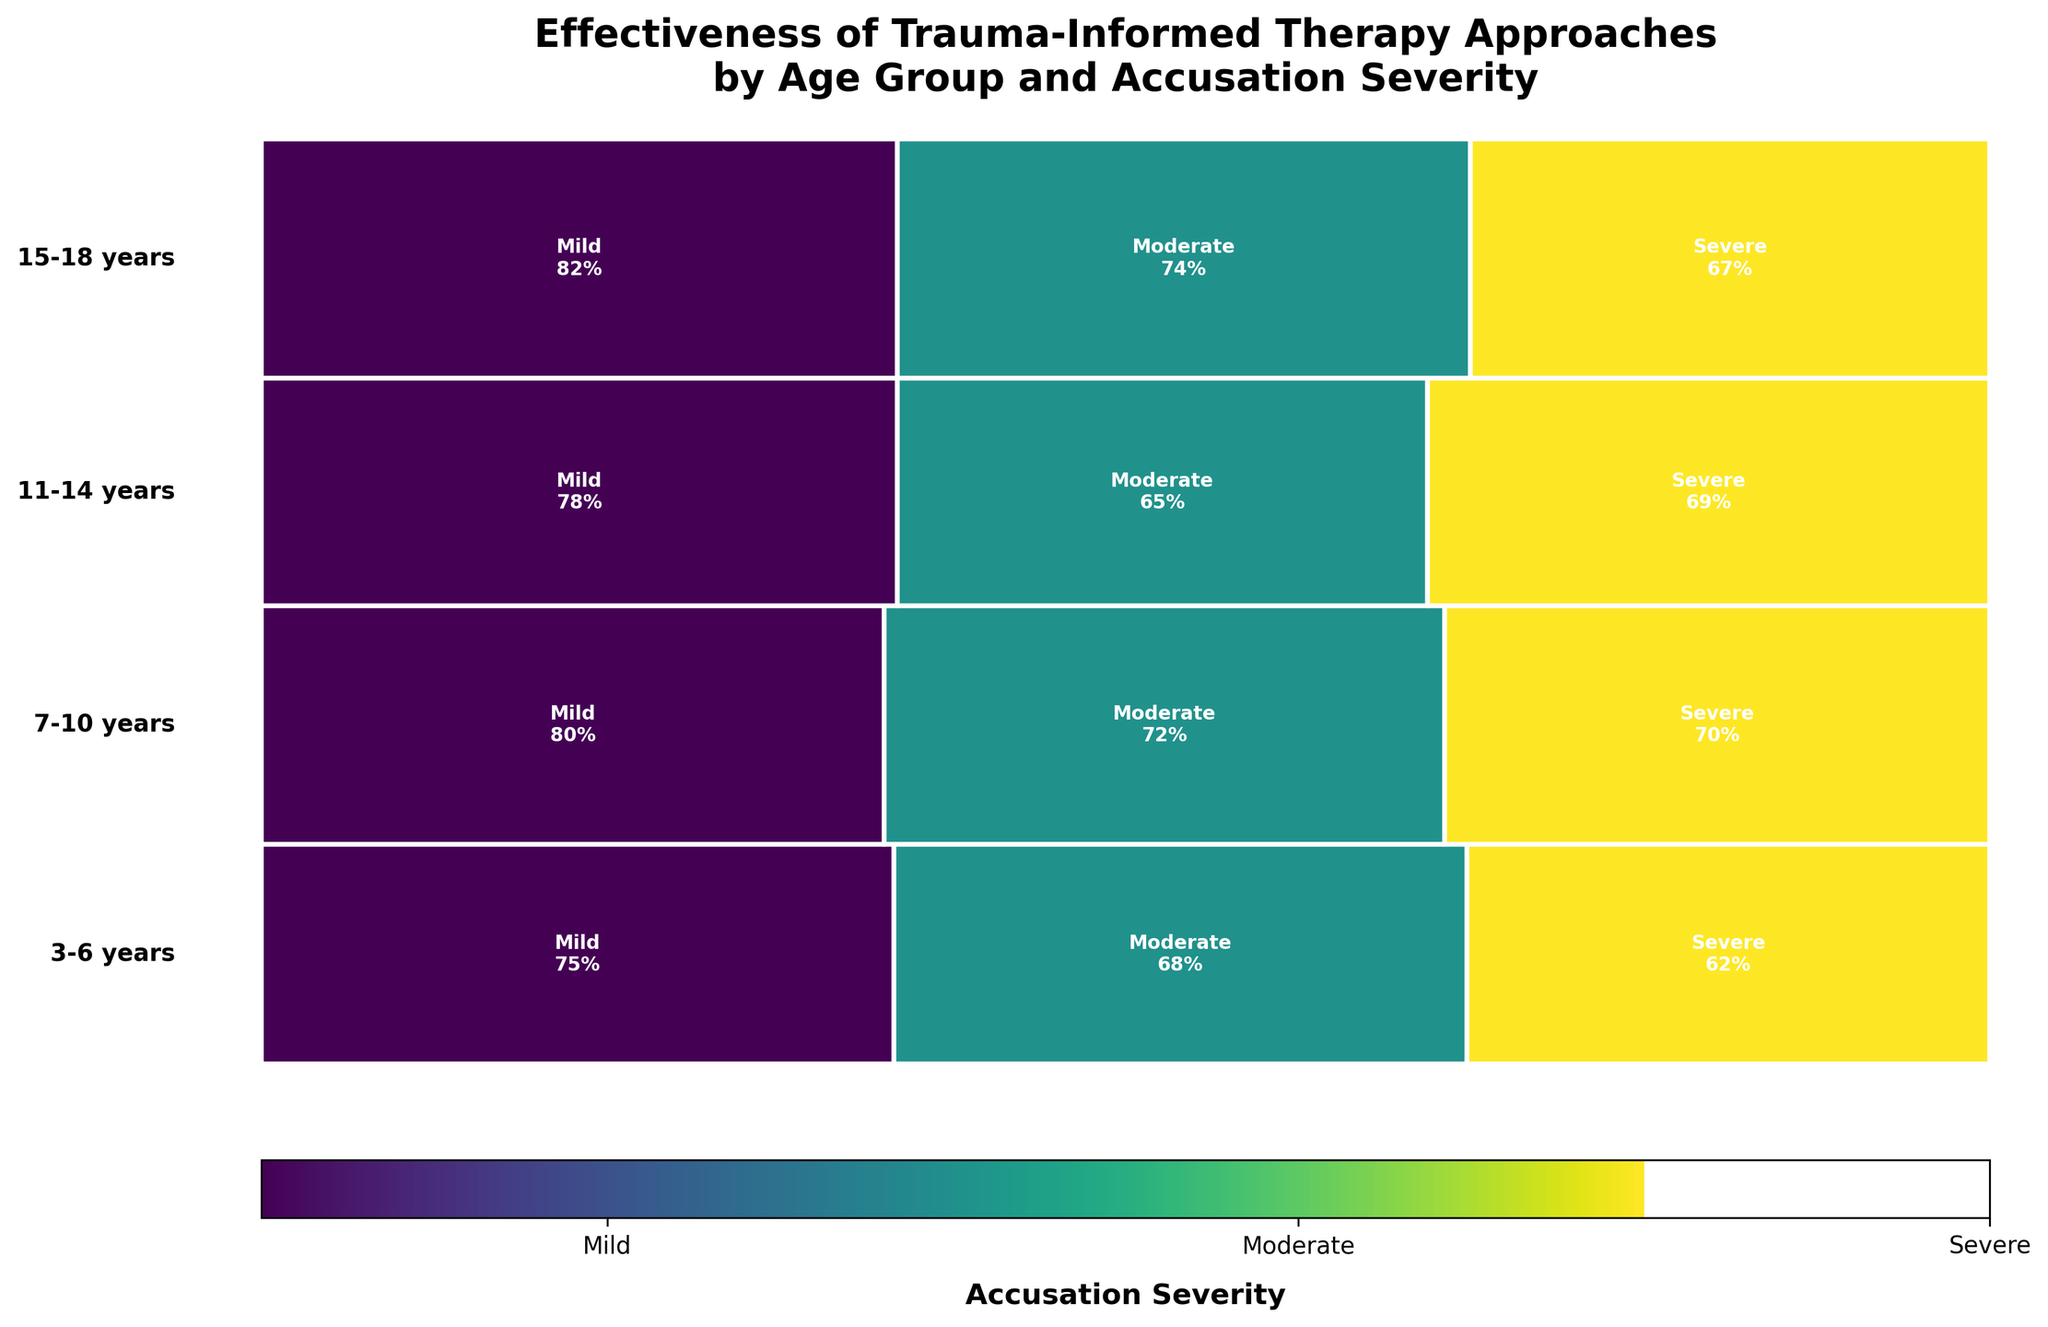How many age groups are depicted in the mosaic plot? There are four age groups in the mosaic plot as labeled on the Y-axis. Each age group corresponds to a specific age range indicated near the corresponding section of the plot.
Answer: 4 Which therapy approach is used for 7-10 years old children with severe accusations? In the section of the plot for 7-10 years old, the rectangle corresponding to severe accusations mentions "Trauma-Focused CBT" along with its effectiveness rate.
Answer: Trauma-Focused CBT Which accusation severity level has the highest effectiveness rate for children aged 15-18 years? In the 15-18 years age section, the rectangle marked "Mild" has the highest effectiveness rate of 82%, as seen from the combined details in it.
Answer: Mild Compare the effectiveness rate of Cognitive Behavioral Therapy for 7-10 years with Solution-Focused Brief Therapy for 15-18 years. Which one is higher? For 7-10 years old with Mild accusations, Cognitive Behavioral Therapy has an effectiveness rate of 80%. For 15-18 years old with Mild accusations, Solution-Focused Brief Therapy has an effectiveness rate of 82%. Thus, Solution-Focused Brief Therapy is higher.
Answer: Solution-Focused Brief Therapy What is the combined effectiveness rate for moderate accusations in the 7-10 and 15-18 age groups? The effectiveness rate for moderate accusations in the 7-10 age group is 72%, and for the 15-18 age group, it is 74%. Combining these gives 72% + 74% = 146%.
Answer: 146% Out of all therapy approaches, which one has the least effectiveness rate and for which age group and severity? Looking at the entire plot, the rectangle for severe accusations in the 3-6 years age group, marked "EMDR," has the lowest effectiveness rate of 62%.
Answer: EMDR, 3-6 years, Severe Which age group has the highest total effectiveness rate for all accusations combined? By observing the sizes of the rectangles, look for the one that appears the largest in the total. 15-18 years seems to encompass the largest area, indicating the highest total effectiveness rate.
Answer: 15-18 years For the 11-14 years age group, which accusation severity level corresponds to the use of Mindfulness-Based Therapy, and what is its effectiveness rate? In the section for 11-14 years, the rectangle labeled with "Mindfulness-Based Therapy" is associated with "Mild" accusations and has an effectiveness rate of 78%.
Answer: Mild, 78% Which therapy approach is listed for moderate accusations in the 11-14 years age group, and how effective is it? The rectangle for moderate accusations within the 11-14 years age group shows "Group Therapy" with an effectiveness rate of 65%.
Answer: Group Therapy, 65% How does the effectiveness rate of Art Therapy for 3-6 years old with moderate accusations compare to Family Systems Therapy for 15-18 years old with moderate accusations? For the 3-6 years age group and moderate accusations, Art Therapy has an effectiveness rate of 68%. For the 15-18 years age group and moderate accusations, Family Systems Therapy has an effectiveness rate of 74%. Family Systems Therapy is more effective.
Answer: Family Systems Therapy 